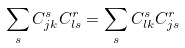<formula> <loc_0><loc_0><loc_500><loc_500>\sum _ { s } C _ { j k } ^ { s } C _ { l s } ^ { r } = \sum _ { s } C _ { l k } ^ { s } C _ { j s } ^ { r }</formula> 